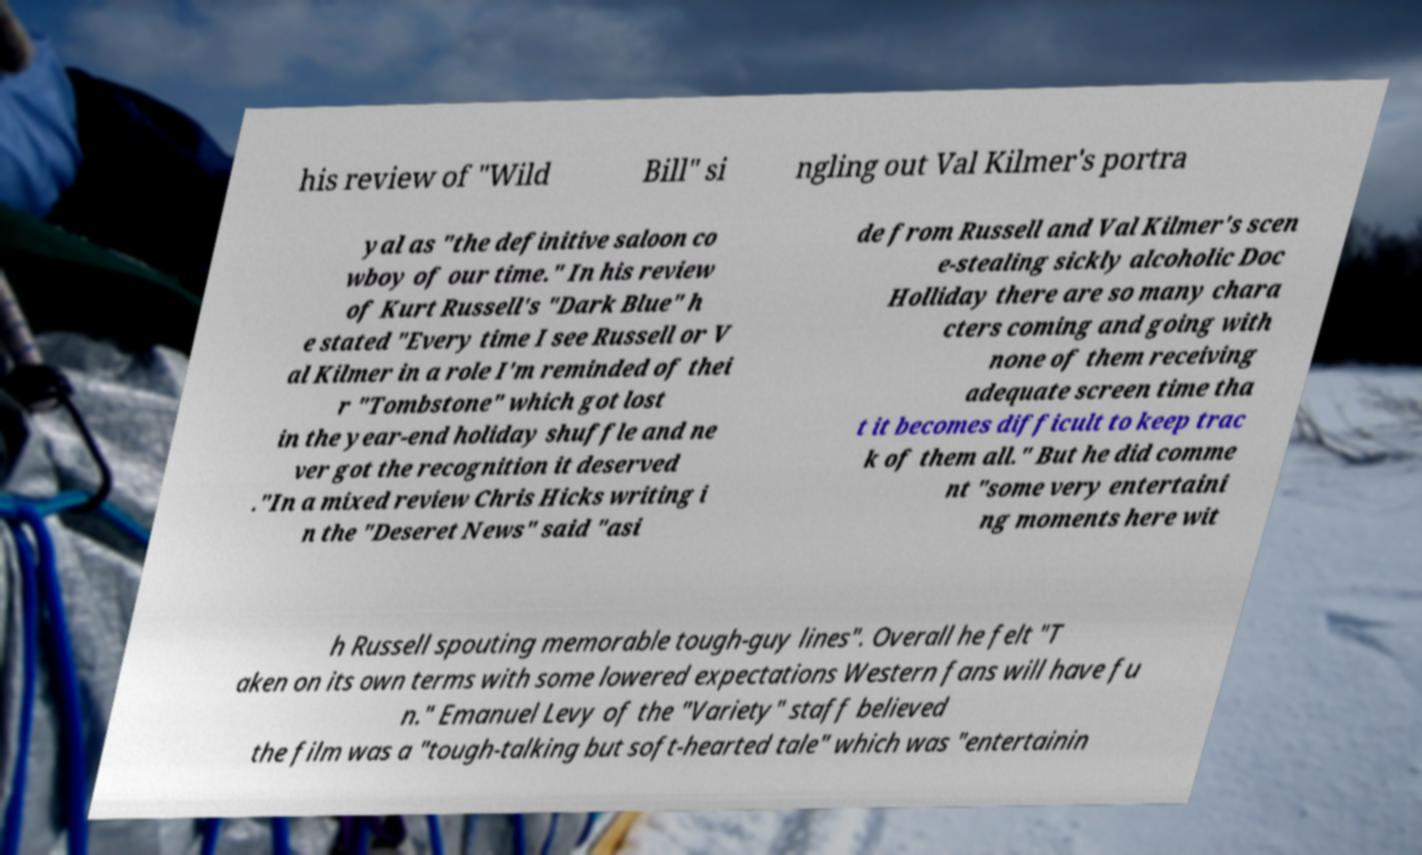Please read and relay the text visible in this image. What does it say? his review of "Wild Bill" si ngling out Val Kilmer's portra yal as "the definitive saloon co wboy of our time." In his review of Kurt Russell's "Dark Blue" h e stated "Every time I see Russell or V al Kilmer in a role I'm reminded of thei r "Tombstone" which got lost in the year-end holiday shuffle and ne ver got the recognition it deserved ."In a mixed review Chris Hicks writing i n the "Deseret News" said "asi de from Russell and Val Kilmer's scen e-stealing sickly alcoholic Doc Holliday there are so many chara cters coming and going with none of them receiving adequate screen time tha t it becomes difficult to keep trac k of them all." But he did comme nt "some very entertaini ng moments here wit h Russell spouting memorable tough-guy lines". Overall he felt "T aken on its own terms with some lowered expectations Western fans will have fu n." Emanuel Levy of the "Variety" staff believed the film was a "tough-talking but soft-hearted tale" which was "entertainin 